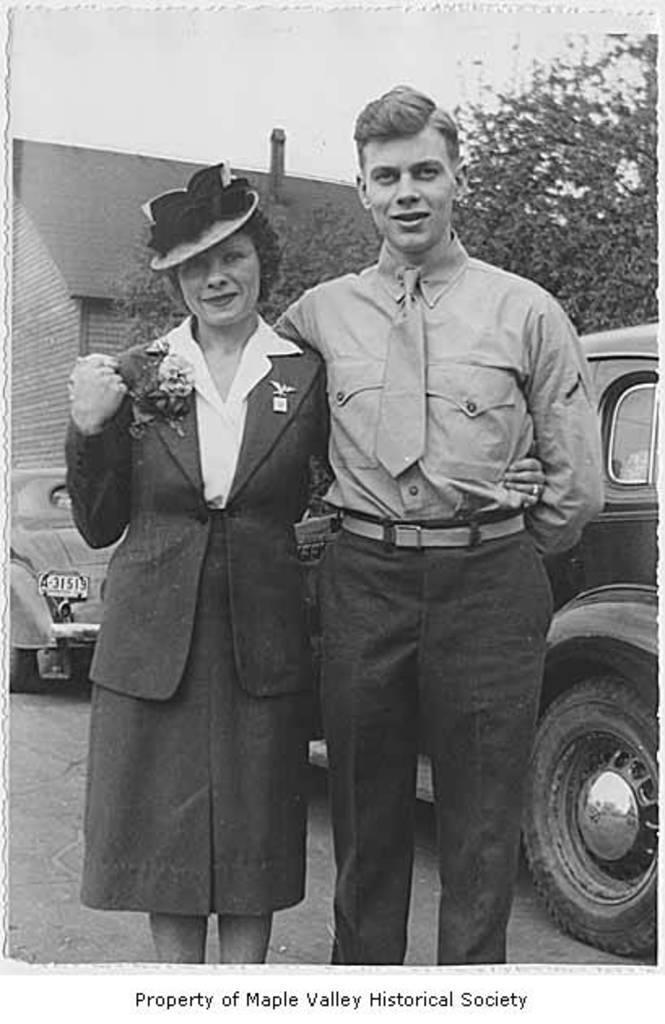Could you give a brief overview of what you see in this image? In this black and white image there is a couple standing, behind them there are two vehicles, building, tree and the sky. 